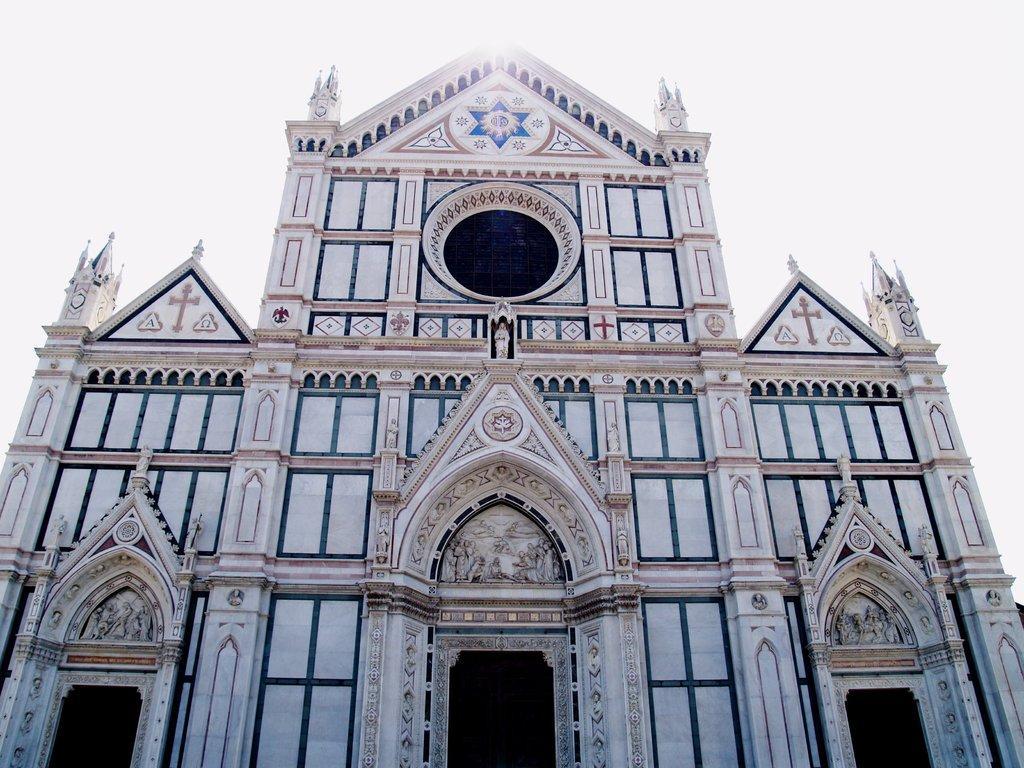How would you summarize this image in a sentence or two? In the image we can see there is a church building. 